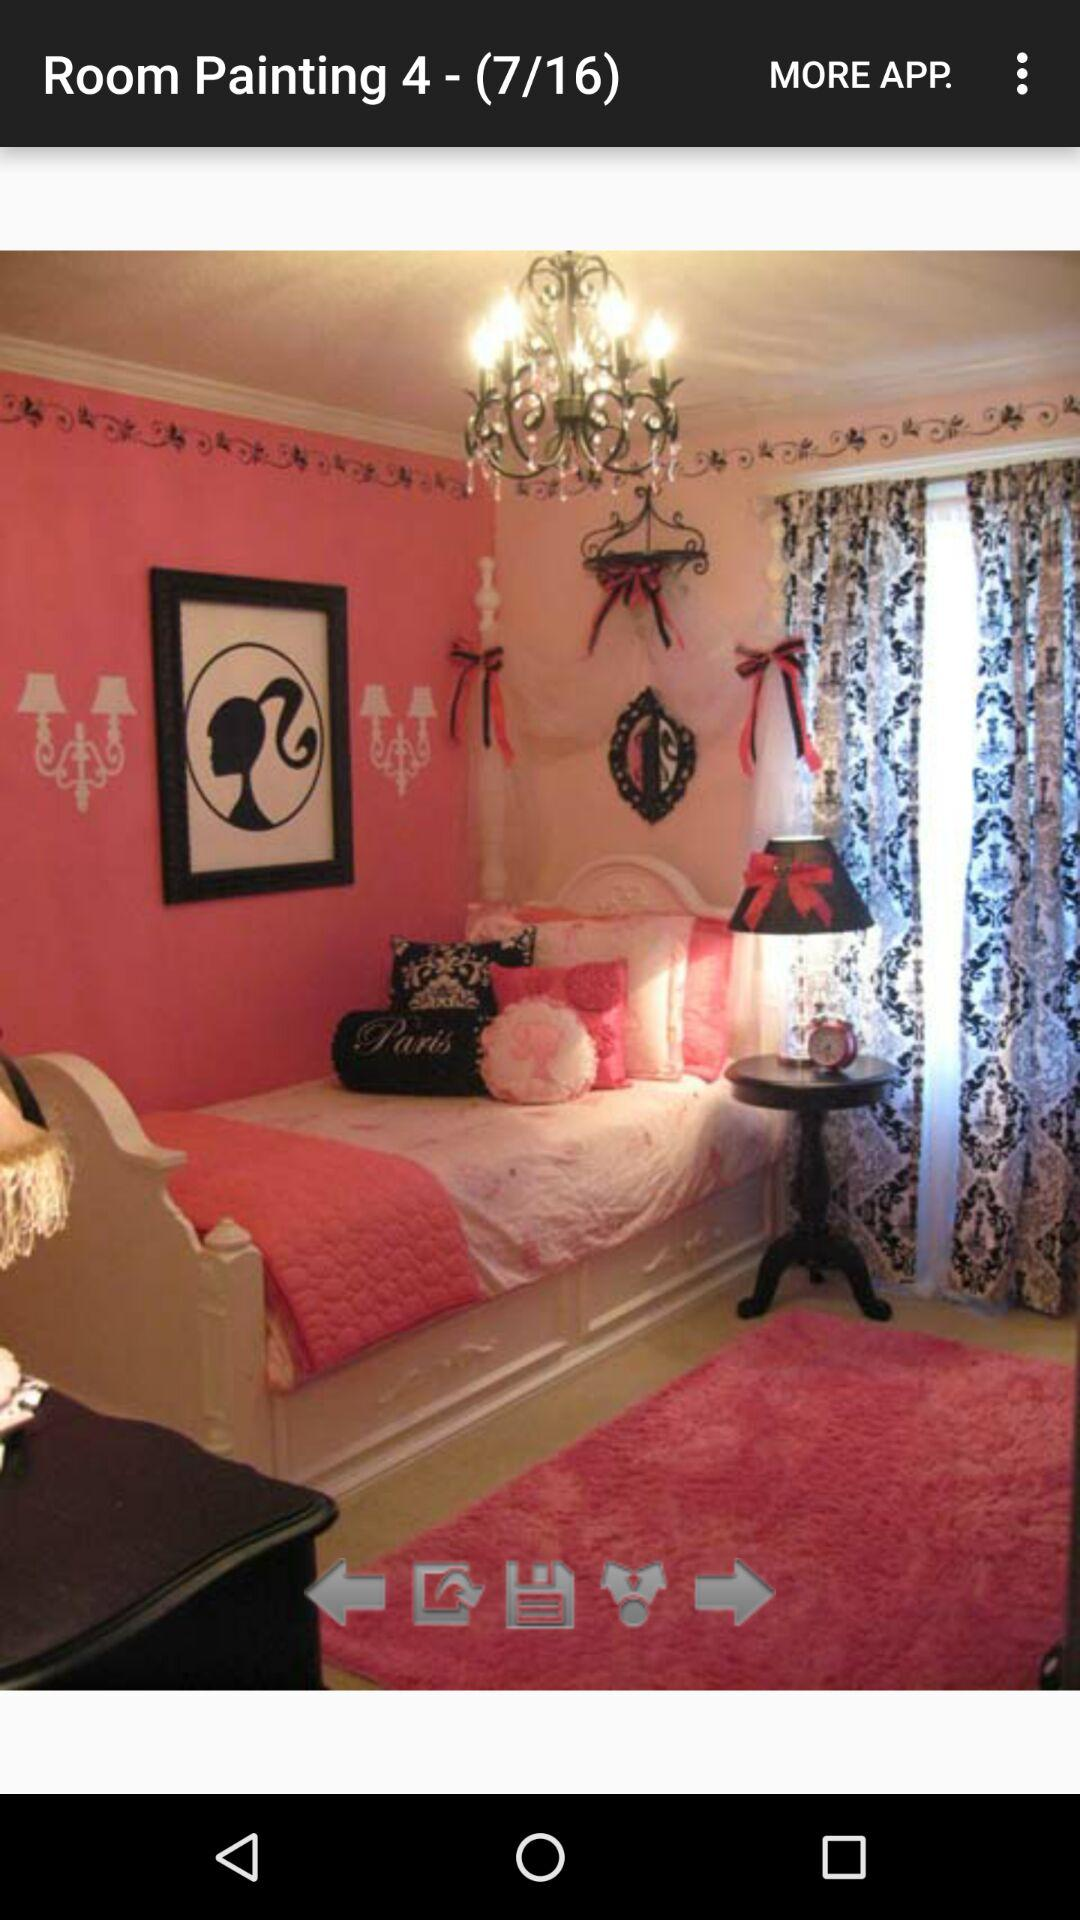Which slide are we on? You are on the seventh slide. 